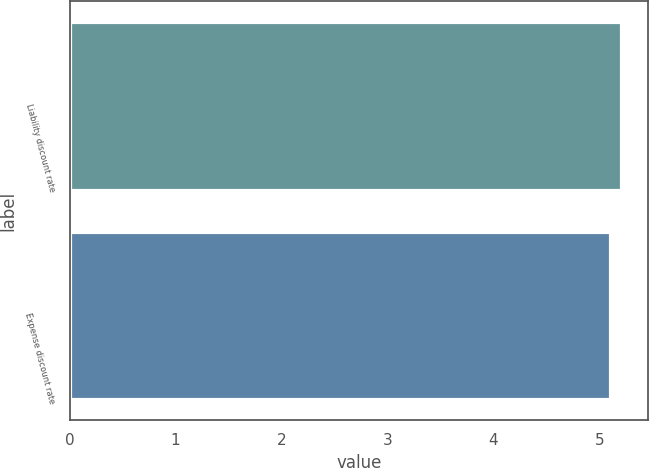Convert chart to OTSL. <chart><loc_0><loc_0><loc_500><loc_500><bar_chart><fcel>Liability discount rate<fcel>Expense discount rate<nl><fcel>5.2<fcel>5.1<nl></chart> 